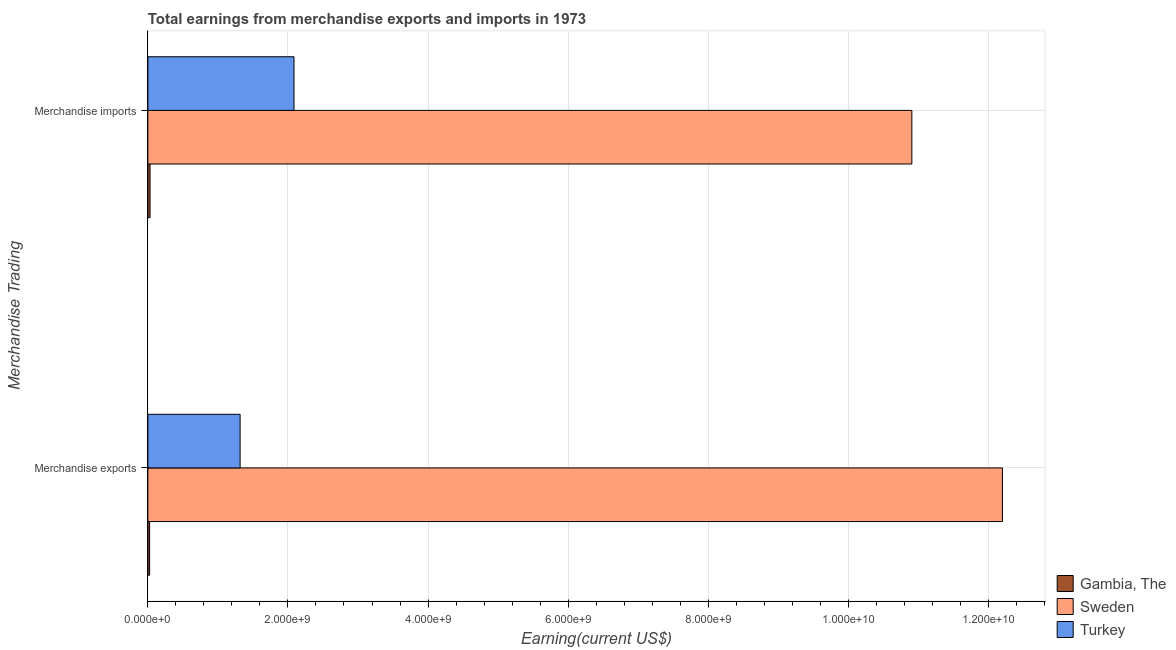How many groups of bars are there?
Keep it short and to the point. 2. How many bars are there on the 2nd tick from the top?
Provide a short and direct response. 3. What is the label of the 1st group of bars from the top?
Make the answer very short. Merchandise imports. What is the earnings from merchandise imports in Turkey?
Your answer should be very brief. 2.09e+09. Across all countries, what is the maximum earnings from merchandise imports?
Provide a short and direct response. 1.09e+1. Across all countries, what is the minimum earnings from merchandise imports?
Ensure brevity in your answer.  3.11e+07. In which country was the earnings from merchandise exports maximum?
Your answer should be very brief. Sweden. In which country was the earnings from merchandise imports minimum?
Offer a very short reply. Gambia, The. What is the total earnings from merchandise exports in the graph?
Your answer should be very brief. 1.35e+1. What is the difference between the earnings from merchandise exports in Turkey and that in Gambia, The?
Ensure brevity in your answer.  1.29e+09. What is the difference between the earnings from merchandise imports in Sweden and the earnings from merchandise exports in Gambia, The?
Give a very brief answer. 1.09e+1. What is the average earnings from merchandise exports per country?
Make the answer very short. 4.51e+09. What is the difference between the earnings from merchandise exports and earnings from merchandise imports in Gambia, The?
Provide a short and direct response. -6.21e+06. In how many countries, is the earnings from merchandise exports greater than 8800000000 US$?
Give a very brief answer. 1. What is the ratio of the earnings from merchandise exports in Turkey to that in Sweden?
Offer a very short reply. 0.11. What does the 1st bar from the bottom in Merchandise imports represents?
Offer a very short reply. Gambia, The. How many bars are there?
Your answer should be compact. 6. Are all the bars in the graph horizontal?
Your answer should be compact. Yes. What is the difference between two consecutive major ticks on the X-axis?
Ensure brevity in your answer.  2.00e+09. Does the graph contain any zero values?
Offer a terse response. No. Where does the legend appear in the graph?
Ensure brevity in your answer.  Bottom right. How many legend labels are there?
Give a very brief answer. 3. How are the legend labels stacked?
Your response must be concise. Vertical. What is the title of the graph?
Keep it short and to the point. Total earnings from merchandise exports and imports in 1973. What is the label or title of the X-axis?
Ensure brevity in your answer.  Earning(current US$). What is the label or title of the Y-axis?
Keep it short and to the point. Merchandise Trading. What is the Earning(current US$) in Gambia, The in Merchandise exports?
Provide a succinct answer. 2.49e+07. What is the Earning(current US$) of Sweden in Merchandise exports?
Your answer should be compact. 1.22e+1. What is the Earning(current US$) in Turkey in Merchandise exports?
Offer a very short reply. 1.32e+09. What is the Earning(current US$) in Gambia, The in Merchandise imports?
Keep it short and to the point. 3.11e+07. What is the Earning(current US$) in Sweden in Merchandise imports?
Provide a short and direct response. 1.09e+1. What is the Earning(current US$) of Turkey in Merchandise imports?
Provide a short and direct response. 2.09e+09. Across all Merchandise Trading, what is the maximum Earning(current US$) in Gambia, The?
Your answer should be very brief. 3.11e+07. Across all Merchandise Trading, what is the maximum Earning(current US$) in Sweden?
Keep it short and to the point. 1.22e+1. Across all Merchandise Trading, what is the maximum Earning(current US$) of Turkey?
Your answer should be compact. 2.09e+09. Across all Merchandise Trading, what is the minimum Earning(current US$) in Gambia, The?
Your answer should be compact. 2.49e+07. Across all Merchandise Trading, what is the minimum Earning(current US$) of Sweden?
Your answer should be very brief. 1.09e+1. Across all Merchandise Trading, what is the minimum Earning(current US$) of Turkey?
Provide a short and direct response. 1.32e+09. What is the total Earning(current US$) of Gambia, The in the graph?
Your answer should be very brief. 5.60e+07. What is the total Earning(current US$) of Sweden in the graph?
Provide a succinct answer. 2.31e+1. What is the total Earning(current US$) of Turkey in the graph?
Offer a terse response. 3.40e+09. What is the difference between the Earning(current US$) in Gambia, The in Merchandise exports and that in Merchandise imports?
Your answer should be compact. -6.21e+06. What is the difference between the Earning(current US$) of Sweden in Merchandise exports and that in Merchandise imports?
Make the answer very short. 1.29e+09. What is the difference between the Earning(current US$) of Turkey in Merchandise exports and that in Merchandise imports?
Your answer should be very brief. -7.69e+08. What is the difference between the Earning(current US$) in Gambia, The in Merchandise exports and the Earning(current US$) in Sweden in Merchandise imports?
Keep it short and to the point. -1.09e+1. What is the difference between the Earning(current US$) of Gambia, The in Merchandise exports and the Earning(current US$) of Turkey in Merchandise imports?
Provide a succinct answer. -2.06e+09. What is the difference between the Earning(current US$) of Sweden in Merchandise exports and the Earning(current US$) of Turkey in Merchandise imports?
Keep it short and to the point. 1.01e+1. What is the average Earning(current US$) of Gambia, The per Merchandise Trading?
Your response must be concise. 2.80e+07. What is the average Earning(current US$) of Sweden per Merchandise Trading?
Give a very brief answer. 1.16e+1. What is the average Earning(current US$) in Turkey per Merchandise Trading?
Offer a terse response. 1.70e+09. What is the difference between the Earning(current US$) of Gambia, The and Earning(current US$) of Sweden in Merchandise exports?
Keep it short and to the point. -1.22e+1. What is the difference between the Earning(current US$) in Gambia, The and Earning(current US$) in Turkey in Merchandise exports?
Offer a terse response. -1.29e+09. What is the difference between the Earning(current US$) in Sweden and Earning(current US$) in Turkey in Merchandise exports?
Your answer should be very brief. 1.09e+1. What is the difference between the Earning(current US$) of Gambia, The and Earning(current US$) of Sweden in Merchandise imports?
Your response must be concise. -1.09e+1. What is the difference between the Earning(current US$) of Gambia, The and Earning(current US$) of Turkey in Merchandise imports?
Ensure brevity in your answer.  -2.06e+09. What is the difference between the Earning(current US$) in Sweden and Earning(current US$) in Turkey in Merchandise imports?
Offer a very short reply. 8.82e+09. What is the ratio of the Earning(current US$) in Gambia, The in Merchandise exports to that in Merchandise imports?
Offer a terse response. 0.8. What is the ratio of the Earning(current US$) of Sweden in Merchandise exports to that in Merchandise imports?
Keep it short and to the point. 1.12. What is the ratio of the Earning(current US$) of Turkey in Merchandise exports to that in Merchandise imports?
Give a very brief answer. 0.63. What is the difference between the highest and the second highest Earning(current US$) of Gambia, The?
Provide a succinct answer. 6.21e+06. What is the difference between the highest and the second highest Earning(current US$) in Sweden?
Your answer should be compact. 1.29e+09. What is the difference between the highest and the second highest Earning(current US$) in Turkey?
Offer a terse response. 7.69e+08. What is the difference between the highest and the lowest Earning(current US$) of Gambia, The?
Give a very brief answer. 6.21e+06. What is the difference between the highest and the lowest Earning(current US$) in Sweden?
Your answer should be compact. 1.29e+09. What is the difference between the highest and the lowest Earning(current US$) of Turkey?
Make the answer very short. 7.69e+08. 